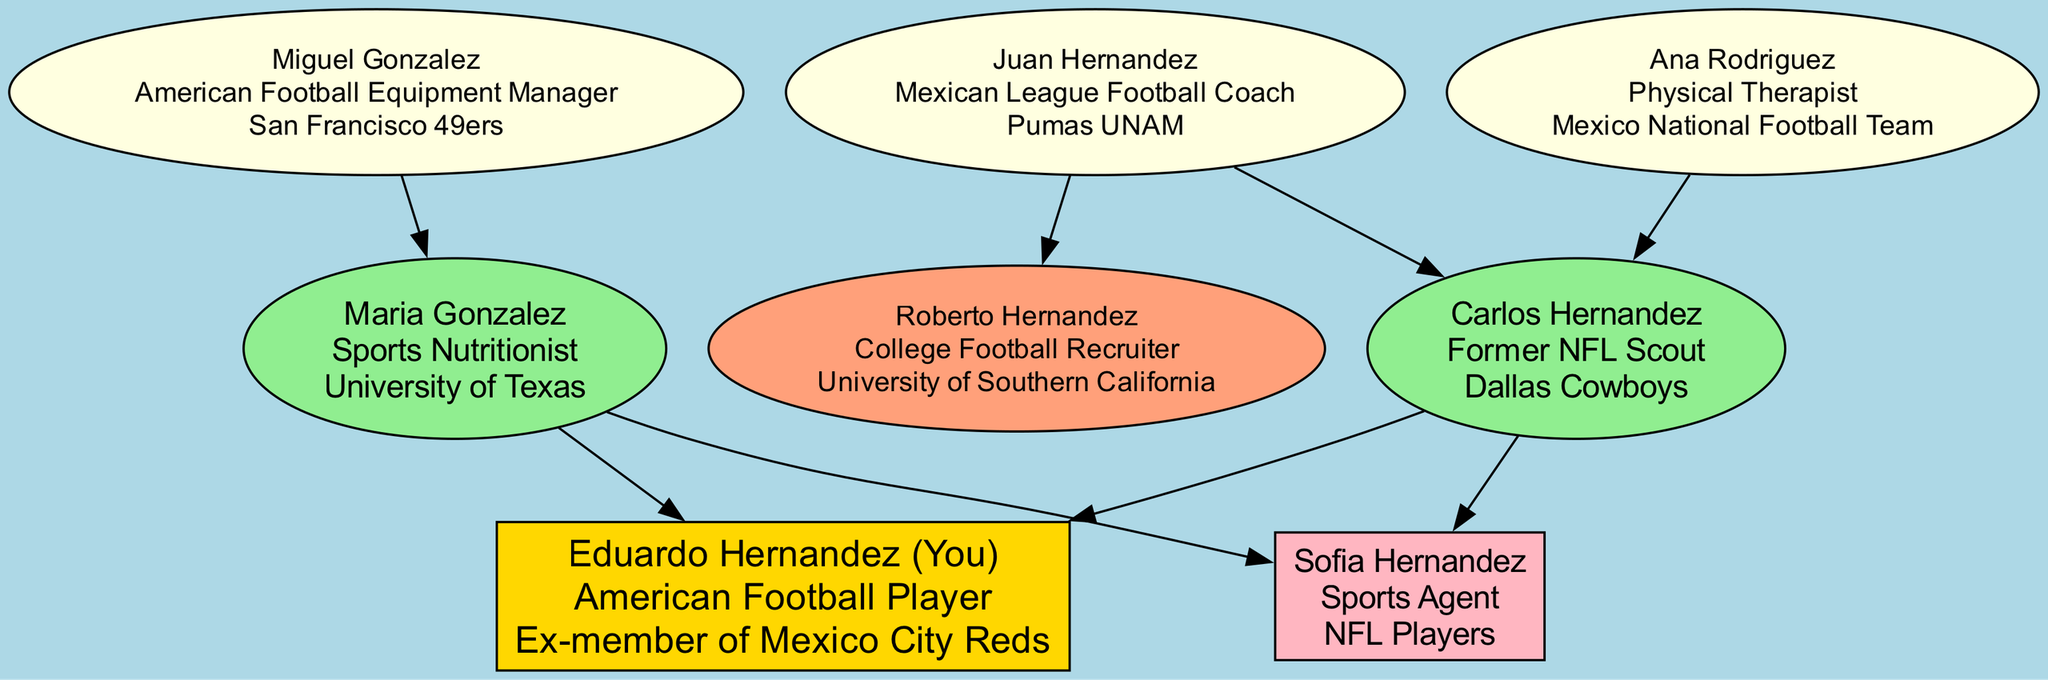What is the occupation of your father? The diagram lists the father as Carlos Hernandez, and under his name, it states "Former NFL Scout." Therefore, the occupation of the father is directly taken from the parent node for Carlos Hernandez.
Answer: Former NFL Scout Who is your sibling? The sibling is represented in the diagram as Sofia Hernandez. Her name is specifically mentioned in the siblings section. Therefore, the answer can be found directly by identifying the sibling node.
Answer: Sofia Hernandez How many grandparents are in the diagram? The diagram shows a total of four grandparents: Juan Hernandez, Ana Rodriguez, Miguel Gonzalez, and one more (the specific name is not mentioned; hence it is counted manually). By visually inspecting the grandparent section of the diagram, we see a total of four nodes.
Answer: 4 Which team did your grandfather Juan Hernandez coach? In the diagram, it states that Juan Hernandez's occupation is "Mexican League Football Coach," and under it, it mentions the team he coached, which is "Pumas UNAM." This information is clearly listed in the grandparent section.
Answer: Pumas UNAM What is your aunt's occupation? The aunt represented in the diagram is not directly labeled as "aunt" but is indicated as one of the uncles/aunts. The diagram specifies that Roberto Hernandez is a College Football Recruiter. As no aunts are specifically mentioned, the answer points to the uncle, which includes family members of similar relation.
Answer: College Football Recruiter What is the relationship between Carlos Hernandez and Sofia Hernandez? In the family tree diagram, Carlos Hernandez is listed as the father while Sofia Hernandez is designated as the sibling. This gives us their direct relationship where he is her parent, and she is his child.
Answer: Father and Sibling How many total nodes represent family members in the diagram? The diagram includes one root (Eduardo Hernandez), two parents, four grandparents, one sibling, and one uncle/aunt. By summing these, we have: 1 (root) + 2 (parents) + 4 (grandparents) + 1 (sibling) + 1 (uncle) = 9 nodes total.
Answer: 9 What is the occupation of your mother? According to the diagram, your mother is named Maria Gonzalez, and her occupation is stated as "Sports Nutritionist." This information is provided directly under her name on the parent node.
Answer: Sports Nutritionist 